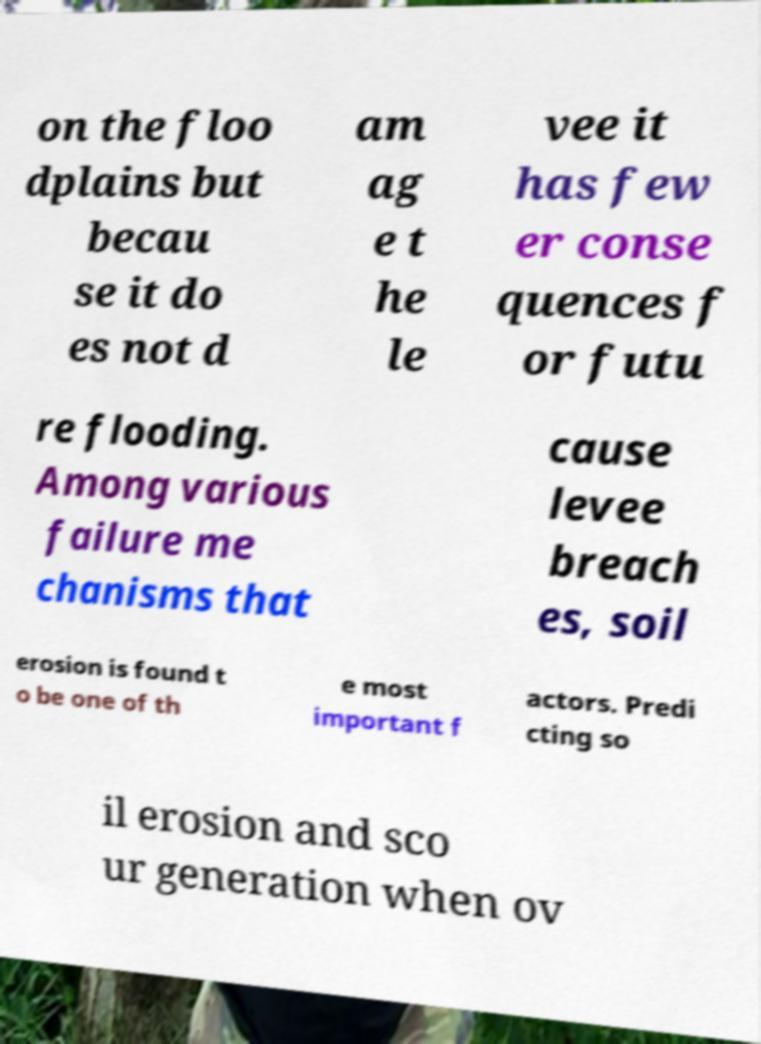There's text embedded in this image that I need extracted. Can you transcribe it verbatim? on the floo dplains but becau se it do es not d am ag e t he le vee it has few er conse quences f or futu re flooding. Among various failure me chanisms that cause levee breach es, soil erosion is found t o be one of th e most important f actors. Predi cting so il erosion and sco ur generation when ov 